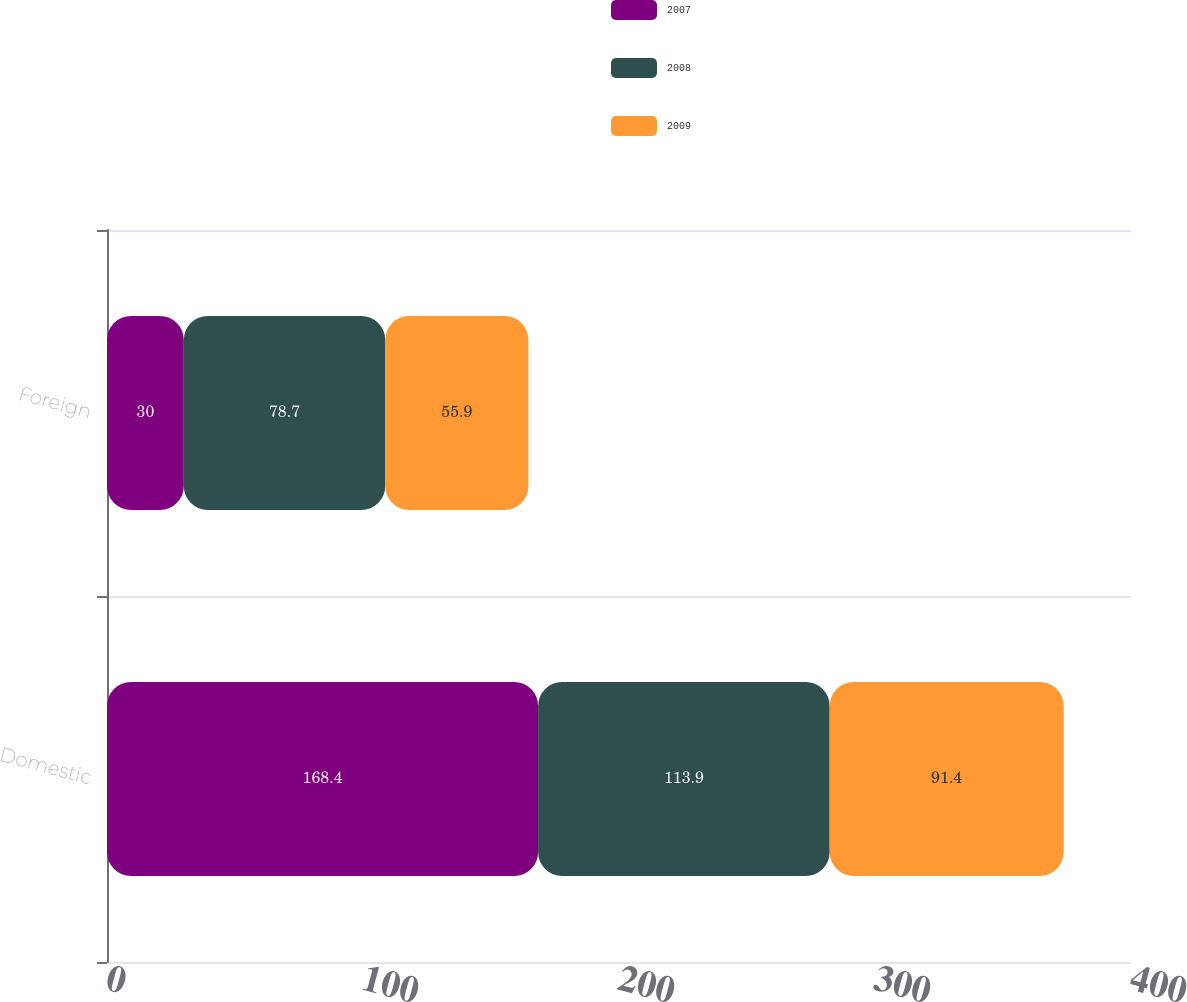Convert chart. <chart><loc_0><loc_0><loc_500><loc_500><stacked_bar_chart><ecel><fcel>Domestic<fcel>Foreign<nl><fcel>2007<fcel>168.4<fcel>30<nl><fcel>2008<fcel>113.9<fcel>78.7<nl><fcel>2009<fcel>91.4<fcel>55.9<nl></chart> 